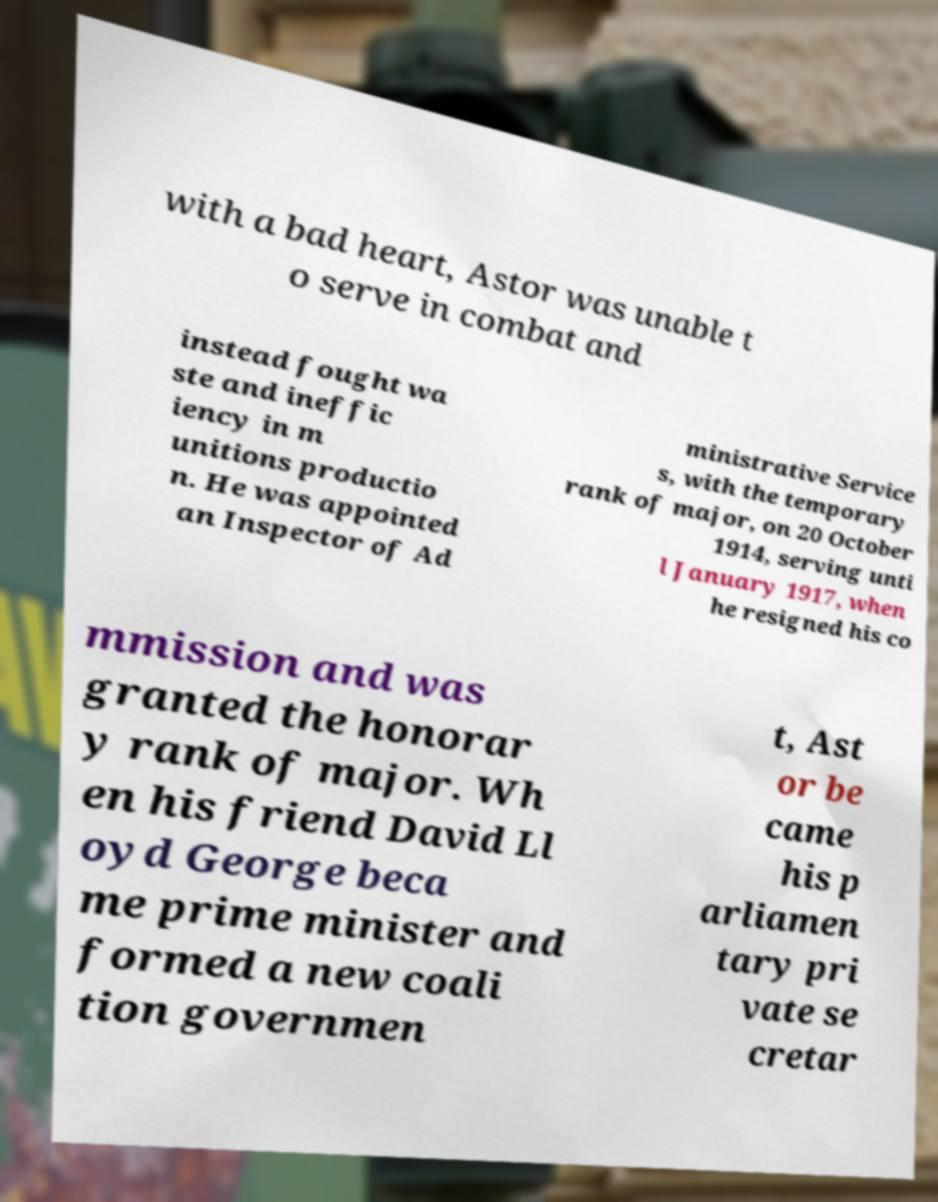Can you read and provide the text displayed in the image?This photo seems to have some interesting text. Can you extract and type it out for me? with a bad heart, Astor was unable t o serve in combat and instead fought wa ste and ineffic iency in m unitions productio n. He was appointed an Inspector of Ad ministrative Service s, with the temporary rank of major, on 20 October 1914, serving unti l January 1917, when he resigned his co mmission and was granted the honorar y rank of major. Wh en his friend David Ll oyd George beca me prime minister and formed a new coali tion governmen t, Ast or be came his p arliamen tary pri vate se cretar 